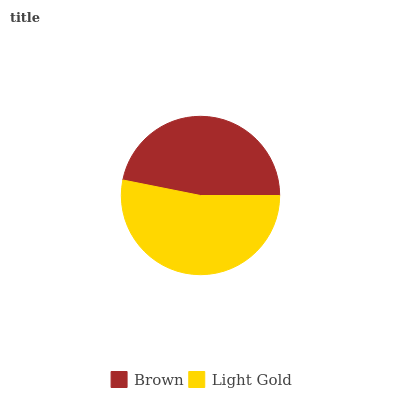Is Brown the minimum?
Answer yes or no. Yes. Is Light Gold the maximum?
Answer yes or no. Yes. Is Light Gold the minimum?
Answer yes or no. No. Is Light Gold greater than Brown?
Answer yes or no. Yes. Is Brown less than Light Gold?
Answer yes or no. Yes. Is Brown greater than Light Gold?
Answer yes or no. No. Is Light Gold less than Brown?
Answer yes or no. No. Is Light Gold the high median?
Answer yes or no. Yes. Is Brown the low median?
Answer yes or no. Yes. Is Brown the high median?
Answer yes or no. No. Is Light Gold the low median?
Answer yes or no. No. 